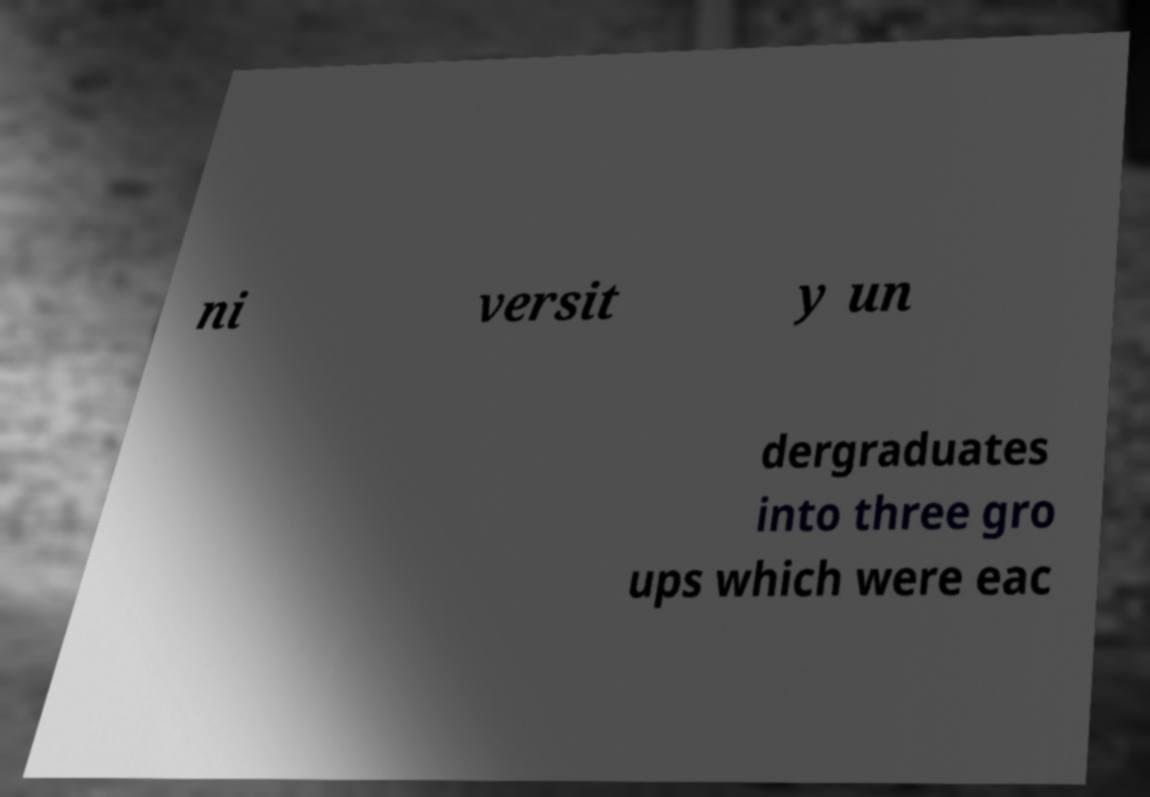Could you assist in decoding the text presented in this image and type it out clearly? ni versit y un dergraduates into three gro ups which were eac 